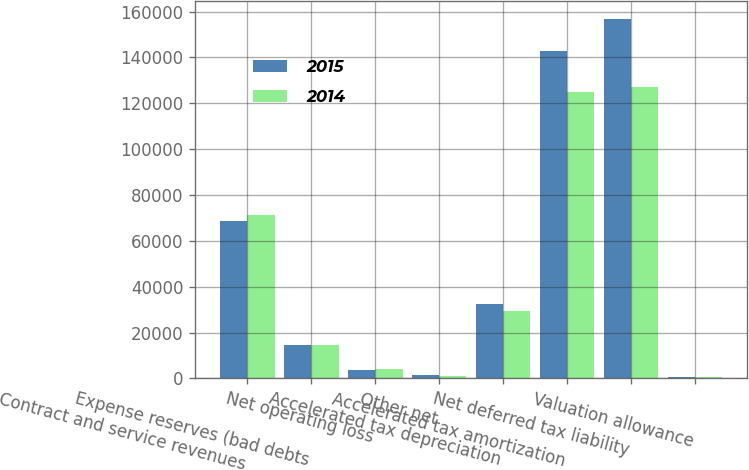<chart> <loc_0><loc_0><loc_500><loc_500><stacked_bar_chart><ecel><fcel>Contract and service revenues<fcel>Expense reserves (bad debts<fcel>Net operating loss<fcel>Other net<fcel>Accelerated tax depreciation<fcel>Accelerated tax amortization<fcel>Net deferred tax liability<fcel>Valuation allowance<nl><fcel>2015<fcel>68503<fcel>14612<fcel>3682<fcel>1493<fcel>32331<fcel>142776<fcel>156607<fcel>650<nl><fcel>2014<fcel>71383<fcel>14776<fcel>4218<fcel>1148<fcel>29247<fcel>125054<fcel>127114<fcel>700<nl></chart> 